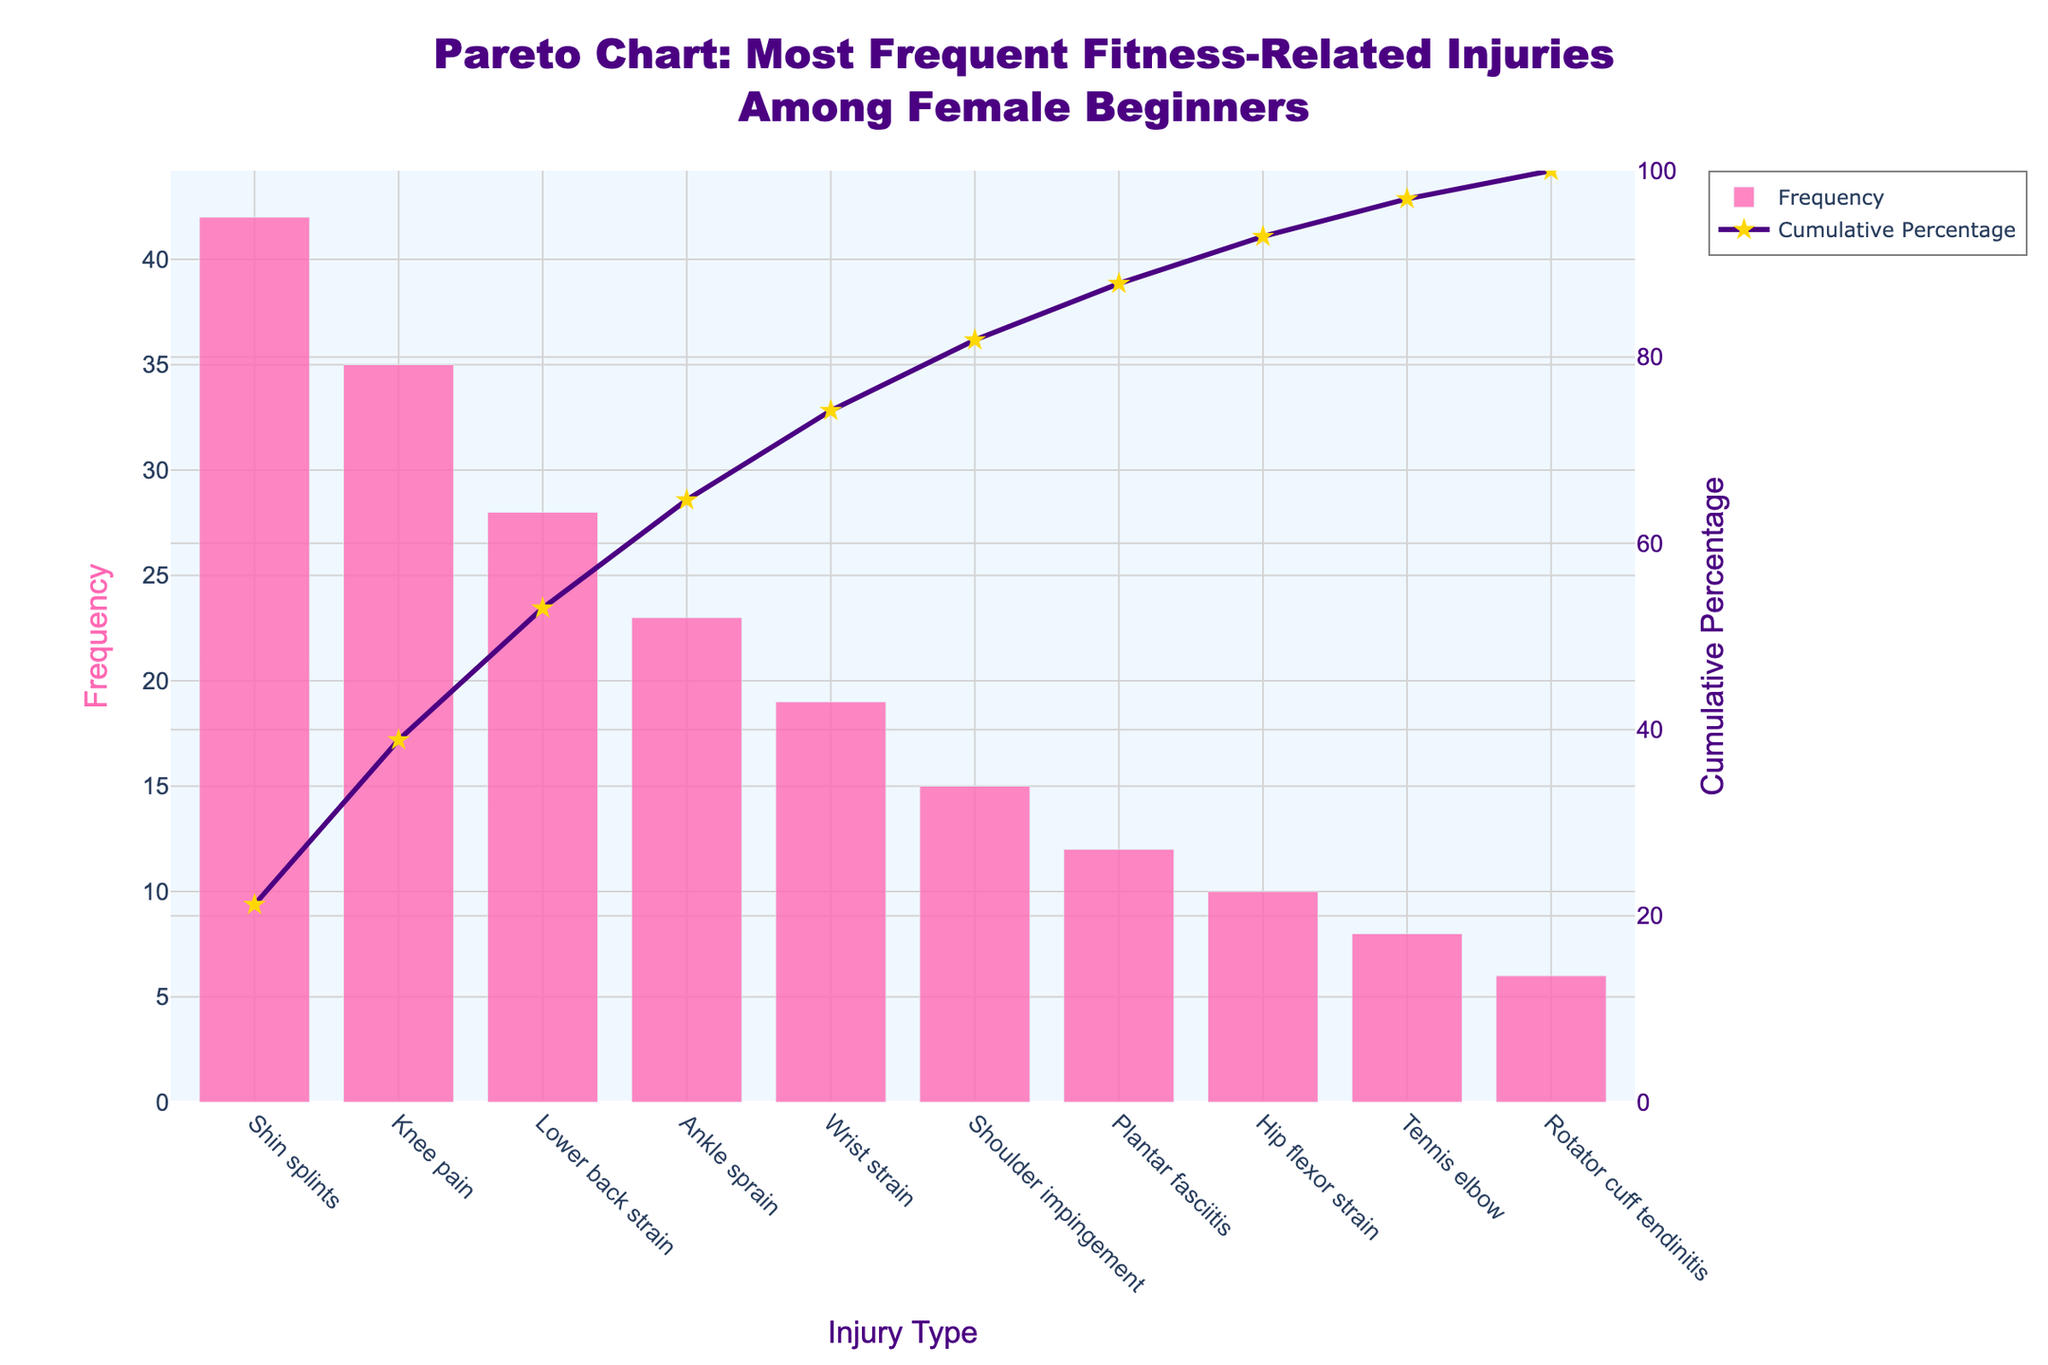What is the title of the chart? The title is located at the top of the chart and reads "Pareto Chart: Most Frequent Fitness-Related Injuries Among Female Beginners".
Answer: Pareto Chart: Most Frequent Fitness-Related Injuries Among Female Beginners Which injury type has the highest frequency? The injury type with the highest frequency is the one with the tallest bar. The tallest bar corresponds to "Shin splints" with a frequency of 42.
Answer: Shin splints What is the cumulative percentage of the first three injury types? The cumulative percentages are indicated by the line marker. For the first three injury types (Shin splints, Knee pain, Lower back strain), their cumulative percentages are 22.28, 40.91, and 55.91 respectively. Summing them up gives 55.91%.
Answer: 55.91% How many injury types have a frequency greater than 20? To find the answer, count the number of bars with a height greater than 20. The injury types are "Shin splints", "Knee pain", "Lower back strain", and "Ankle sprain", totaling four.
Answer: 4 What is the color of the bars in the chart? The bars in the chart are colored in a pink shade, indicated by the visual opacity.
Answer: Pink Which injury type has the lowest cumulative percentage? The cumulative percentage line touches each injury type. The last injury type, "Rotator cuff tendinitis", has the lowest cumulative percentage, which is 100%.
Answer: Rotator cuff tendinitis What is the difference in frequency between the most common and least common injury? Subtract the frequency of the least common injury ("Rotator cuff tendinitis" with a frequency of 6) from the most common injury ("Shin splints" with a frequency of 42). The difference is 42 - 6.
Answer: 36 For which injury types is the cumulative percentage above 75%? The cumulative percentage line above 75% corresponds to the injury types starting from "Shoulder impingement" to "Rotator cuff tendinitis". Specifically, these are "Shoulder impingement", "Plantar fasciitis", "Hip flexor strain", "Tennis elbow", and "Rotator cuff tendinitis".
Answer: Shoulder impingement, Plantar fasciitis, Hip flexor strain, Tennis elbow, Rotator cuff tendinitis How many injury types have a frequency less than 10? Count the bars with a height less than 10. The injury types are "Tennis elbow" and "Rotator cuff tendinitis", totaling two.
Answer: 2 